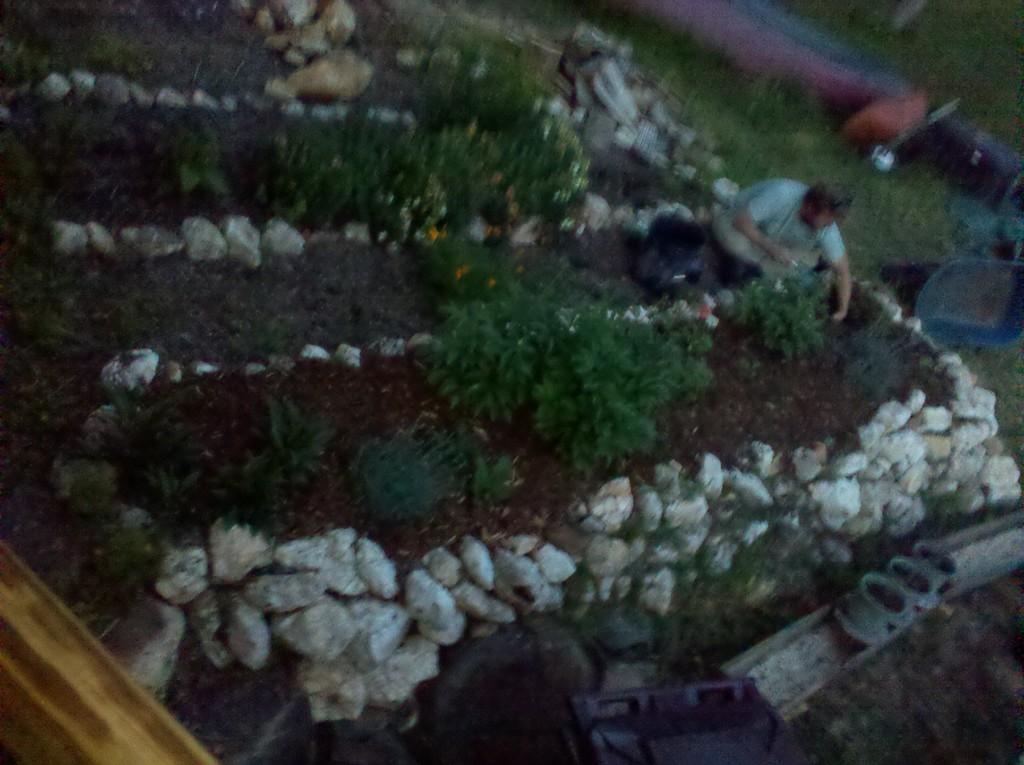Describe this image in one or two sentences. In this image, we can see a person wearing clothes. There are some plants in between rocks. 